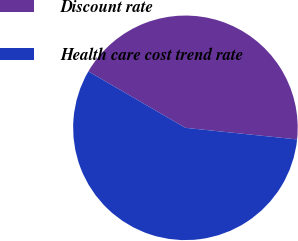Convert chart. <chart><loc_0><loc_0><loc_500><loc_500><pie_chart><fcel>Discount rate<fcel>Health care cost trend rate<nl><fcel>43.27%<fcel>56.73%<nl></chart> 